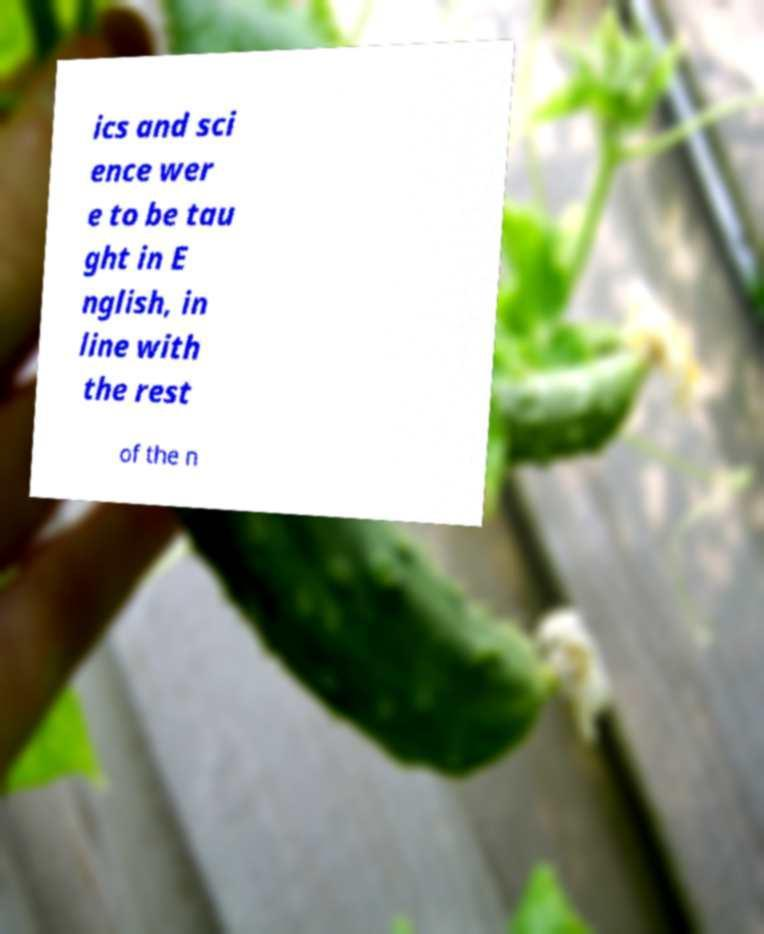Please read and relay the text visible in this image. What does it say? ics and sci ence wer e to be tau ght in E nglish, in line with the rest of the n 